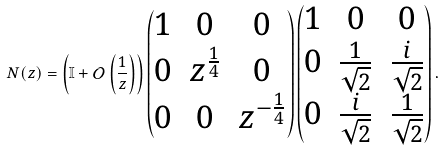Convert formula to latex. <formula><loc_0><loc_0><loc_500><loc_500>N ( z ) = \left ( \mathbb { I } + \mathcal { O } \left ( \frac { 1 } { z } \right ) \right ) \begin{pmatrix} 1 & 0 & 0 \\ 0 & z ^ { \frac { 1 } { 4 } } & 0 \\ 0 & 0 & z ^ { - \frac { 1 } { 4 } } \end{pmatrix} \begin{pmatrix} 1 & 0 & 0 \\ 0 & \frac { 1 } { \sqrt { 2 } } & \frac { i } { \sqrt { 2 } } \\ 0 & \frac { i } { \sqrt { 2 } } & \frac { 1 } { \sqrt { 2 } } \end{pmatrix} .</formula> 